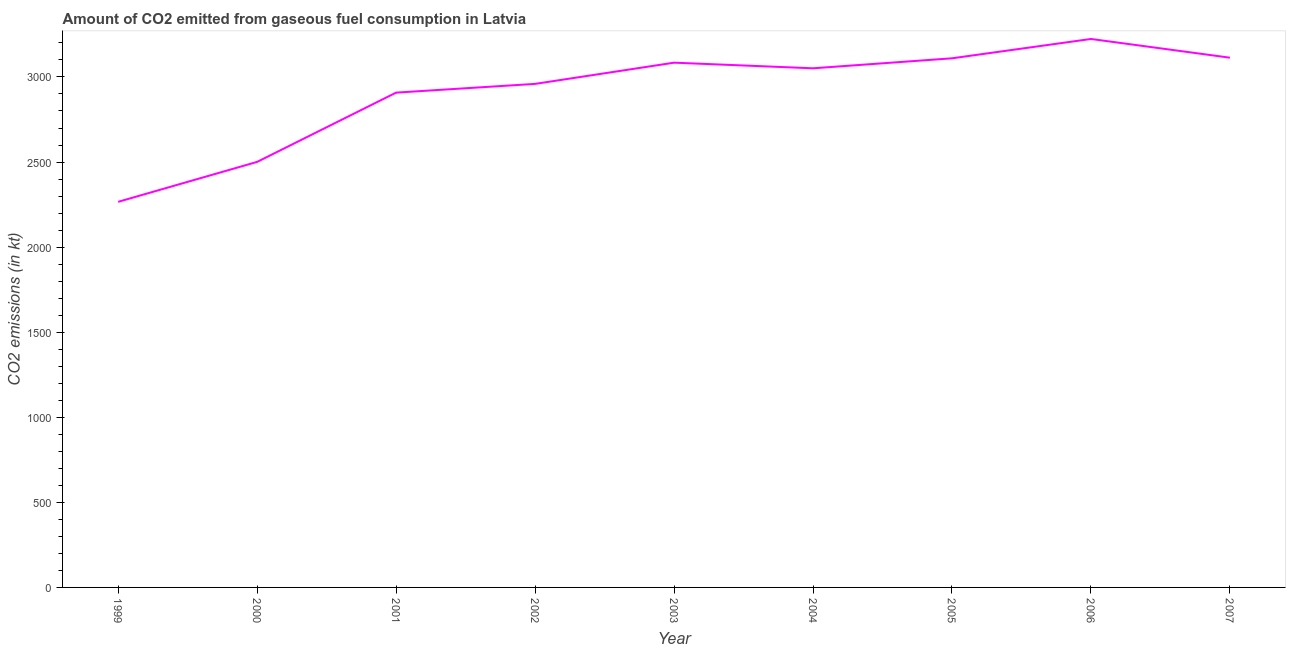What is the co2 emissions from gaseous fuel consumption in 1999?
Provide a succinct answer. 2266.21. Across all years, what is the maximum co2 emissions from gaseous fuel consumption?
Your response must be concise. 3223.29. Across all years, what is the minimum co2 emissions from gaseous fuel consumption?
Give a very brief answer. 2266.21. In which year was the co2 emissions from gaseous fuel consumption maximum?
Give a very brief answer. 2006. What is the sum of the co2 emissions from gaseous fuel consumption?
Make the answer very short. 2.62e+04. What is the difference between the co2 emissions from gaseous fuel consumption in 2000 and 2001?
Offer a very short reply. -407.04. What is the average co2 emissions from gaseous fuel consumption per year?
Provide a short and direct response. 2912.82. What is the median co2 emissions from gaseous fuel consumption?
Offer a very short reply. 3050.94. Do a majority of the years between 2000 and 2002 (inclusive) have co2 emissions from gaseous fuel consumption greater than 1300 kt?
Keep it short and to the point. Yes. What is the ratio of the co2 emissions from gaseous fuel consumption in 1999 to that in 2003?
Give a very brief answer. 0.73. Is the co2 emissions from gaseous fuel consumption in 2001 less than that in 2006?
Offer a terse response. Yes. Is the difference between the co2 emissions from gaseous fuel consumption in 2000 and 2006 greater than the difference between any two years?
Give a very brief answer. No. What is the difference between the highest and the second highest co2 emissions from gaseous fuel consumption?
Ensure brevity in your answer.  110.01. What is the difference between the highest and the lowest co2 emissions from gaseous fuel consumption?
Provide a short and direct response. 957.09. How many years are there in the graph?
Offer a very short reply. 9. Are the values on the major ticks of Y-axis written in scientific E-notation?
Offer a terse response. No. What is the title of the graph?
Offer a terse response. Amount of CO2 emitted from gaseous fuel consumption in Latvia. What is the label or title of the X-axis?
Your answer should be very brief. Year. What is the label or title of the Y-axis?
Make the answer very short. CO2 emissions (in kt). What is the CO2 emissions (in kt) of 1999?
Your answer should be very brief. 2266.21. What is the CO2 emissions (in kt) of 2000?
Your answer should be very brief. 2500.89. What is the CO2 emissions (in kt) of 2001?
Give a very brief answer. 2907.93. What is the CO2 emissions (in kt) of 2002?
Your response must be concise. 2959.27. What is the CO2 emissions (in kt) of 2003?
Make the answer very short. 3083.95. What is the CO2 emissions (in kt) in 2004?
Your answer should be very brief. 3050.94. What is the CO2 emissions (in kt) of 2005?
Provide a succinct answer. 3109.62. What is the CO2 emissions (in kt) of 2006?
Your response must be concise. 3223.29. What is the CO2 emissions (in kt) of 2007?
Provide a succinct answer. 3113.28. What is the difference between the CO2 emissions (in kt) in 1999 and 2000?
Your answer should be compact. -234.69. What is the difference between the CO2 emissions (in kt) in 1999 and 2001?
Ensure brevity in your answer.  -641.73. What is the difference between the CO2 emissions (in kt) in 1999 and 2002?
Offer a terse response. -693.06. What is the difference between the CO2 emissions (in kt) in 1999 and 2003?
Provide a succinct answer. -817.74. What is the difference between the CO2 emissions (in kt) in 1999 and 2004?
Offer a terse response. -784.74. What is the difference between the CO2 emissions (in kt) in 1999 and 2005?
Offer a very short reply. -843.41. What is the difference between the CO2 emissions (in kt) in 1999 and 2006?
Make the answer very short. -957.09. What is the difference between the CO2 emissions (in kt) in 1999 and 2007?
Ensure brevity in your answer.  -847.08. What is the difference between the CO2 emissions (in kt) in 2000 and 2001?
Give a very brief answer. -407.04. What is the difference between the CO2 emissions (in kt) in 2000 and 2002?
Your answer should be compact. -458.38. What is the difference between the CO2 emissions (in kt) in 2000 and 2003?
Offer a very short reply. -583.05. What is the difference between the CO2 emissions (in kt) in 2000 and 2004?
Make the answer very short. -550.05. What is the difference between the CO2 emissions (in kt) in 2000 and 2005?
Ensure brevity in your answer.  -608.72. What is the difference between the CO2 emissions (in kt) in 2000 and 2006?
Provide a short and direct response. -722.4. What is the difference between the CO2 emissions (in kt) in 2000 and 2007?
Make the answer very short. -612.39. What is the difference between the CO2 emissions (in kt) in 2001 and 2002?
Offer a terse response. -51.34. What is the difference between the CO2 emissions (in kt) in 2001 and 2003?
Offer a terse response. -176.02. What is the difference between the CO2 emissions (in kt) in 2001 and 2004?
Your response must be concise. -143.01. What is the difference between the CO2 emissions (in kt) in 2001 and 2005?
Your answer should be very brief. -201.69. What is the difference between the CO2 emissions (in kt) in 2001 and 2006?
Provide a short and direct response. -315.36. What is the difference between the CO2 emissions (in kt) in 2001 and 2007?
Offer a terse response. -205.35. What is the difference between the CO2 emissions (in kt) in 2002 and 2003?
Offer a very short reply. -124.68. What is the difference between the CO2 emissions (in kt) in 2002 and 2004?
Ensure brevity in your answer.  -91.67. What is the difference between the CO2 emissions (in kt) in 2002 and 2005?
Provide a short and direct response. -150.35. What is the difference between the CO2 emissions (in kt) in 2002 and 2006?
Make the answer very short. -264.02. What is the difference between the CO2 emissions (in kt) in 2002 and 2007?
Provide a short and direct response. -154.01. What is the difference between the CO2 emissions (in kt) in 2003 and 2004?
Offer a terse response. 33. What is the difference between the CO2 emissions (in kt) in 2003 and 2005?
Make the answer very short. -25.67. What is the difference between the CO2 emissions (in kt) in 2003 and 2006?
Your answer should be compact. -139.35. What is the difference between the CO2 emissions (in kt) in 2003 and 2007?
Offer a very short reply. -29.34. What is the difference between the CO2 emissions (in kt) in 2004 and 2005?
Offer a terse response. -58.67. What is the difference between the CO2 emissions (in kt) in 2004 and 2006?
Ensure brevity in your answer.  -172.35. What is the difference between the CO2 emissions (in kt) in 2004 and 2007?
Your answer should be compact. -62.34. What is the difference between the CO2 emissions (in kt) in 2005 and 2006?
Make the answer very short. -113.68. What is the difference between the CO2 emissions (in kt) in 2005 and 2007?
Your answer should be compact. -3.67. What is the difference between the CO2 emissions (in kt) in 2006 and 2007?
Keep it short and to the point. 110.01. What is the ratio of the CO2 emissions (in kt) in 1999 to that in 2000?
Offer a very short reply. 0.91. What is the ratio of the CO2 emissions (in kt) in 1999 to that in 2001?
Offer a very short reply. 0.78. What is the ratio of the CO2 emissions (in kt) in 1999 to that in 2002?
Offer a very short reply. 0.77. What is the ratio of the CO2 emissions (in kt) in 1999 to that in 2003?
Offer a terse response. 0.73. What is the ratio of the CO2 emissions (in kt) in 1999 to that in 2004?
Your answer should be very brief. 0.74. What is the ratio of the CO2 emissions (in kt) in 1999 to that in 2005?
Make the answer very short. 0.73. What is the ratio of the CO2 emissions (in kt) in 1999 to that in 2006?
Give a very brief answer. 0.7. What is the ratio of the CO2 emissions (in kt) in 1999 to that in 2007?
Offer a terse response. 0.73. What is the ratio of the CO2 emissions (in kt) in 2000 to that in 2001?
Ensure brevity in your answer.  0.86. What is the ratio of the CO2 emissions (in kt) in 2000 to that in 2002?
Ensure brevity in your answer.  0.84. What is the ratio of the CO2 emissions (in kt) in 2000 to that in 2003?
Ensure brevity in your answer.  0.81. What is the ratio of the CO2 emissions (in kt) in 2000 to that in 2004?
Ensure brevity in your answer.  0.82. What is the ratio of the CO2 emissions (in kt) in 2000 to that in 2005?
Provide a short and direct response. 0.8. What is the ratio of the CO2 emissions (in kt) in 2000 to that in 2006?
Your response must be concise. 0.78. What is the ratio of the CO2 emissions (in kt) in 2000 to that in 2007?
Provide a succinct answer. 0.8. What is the ratio of the CO2 emissions (in kt) in 2001 to that in 2003?
Give a very brief answer. 0.94. What is the ratio of the CO2 emissions (in kt) in 2001 to that in 2004?
Your response must be concise. 0.95. What is the ratio of the CO2 emissions (in kt) in 2001 to that in 2005?
Make the answer very short. 0.94. What is the ratio of the CO2 emissions (in kt) in 2001 to that in 2006?
Give a very brief answer. 0.9. What is the ratio of the CO2 emissions (in kt) in 2001 to that in 2007?
Offer a terse response. 0.93. What is the ratio of the CO2 emissions (in kt) in 2002 to that in 2004?
Offer a terse response. 0.97. What is the ratio of the CO2 emissions (in kt) in 2002 to that in 2006?
Keep it short and to the point. 0.92. What is the ratio of the CO2 emissions (in kt) in 2002 to that in 2007?
Provide a succinct answer. 0.95. What is the ratio of the CO2 emissions (in kt) in 2003 to that in 2004?
Your response must be concise. 1.01. What is the ratio of the CO2 emissions (in kt) in 2004 to that in 2006?
Your answer should be very brief. 0.95. What is the ratio of the CO2 emissions (in kt) in 2004 to that in 2007?
Your answer should be very brief. 0.98. What is the ratio of the CO2 emissions (in kt) in 2005 to that in 2006?
Your answer should be very brief. 0.96. What is the ratio of the CO2 emissions (in kt) in 2005 to that in 2007?
Ensure brevity in your answer.  1. What is the ratio of the CO2 emissions (in kt) in 2006 to that in 2007?
Ensure brevity in your answer.  1.03. 